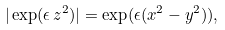Convert formula to latex. <formula><loc_0><loc_0><loc_500><loc_500>| \exp ( \epsilon \, z ^ { 2 } ) | = \exp ( \epsilon ( x ^ { 2 } - y ^ { 2 } ) ) ,</formula> 